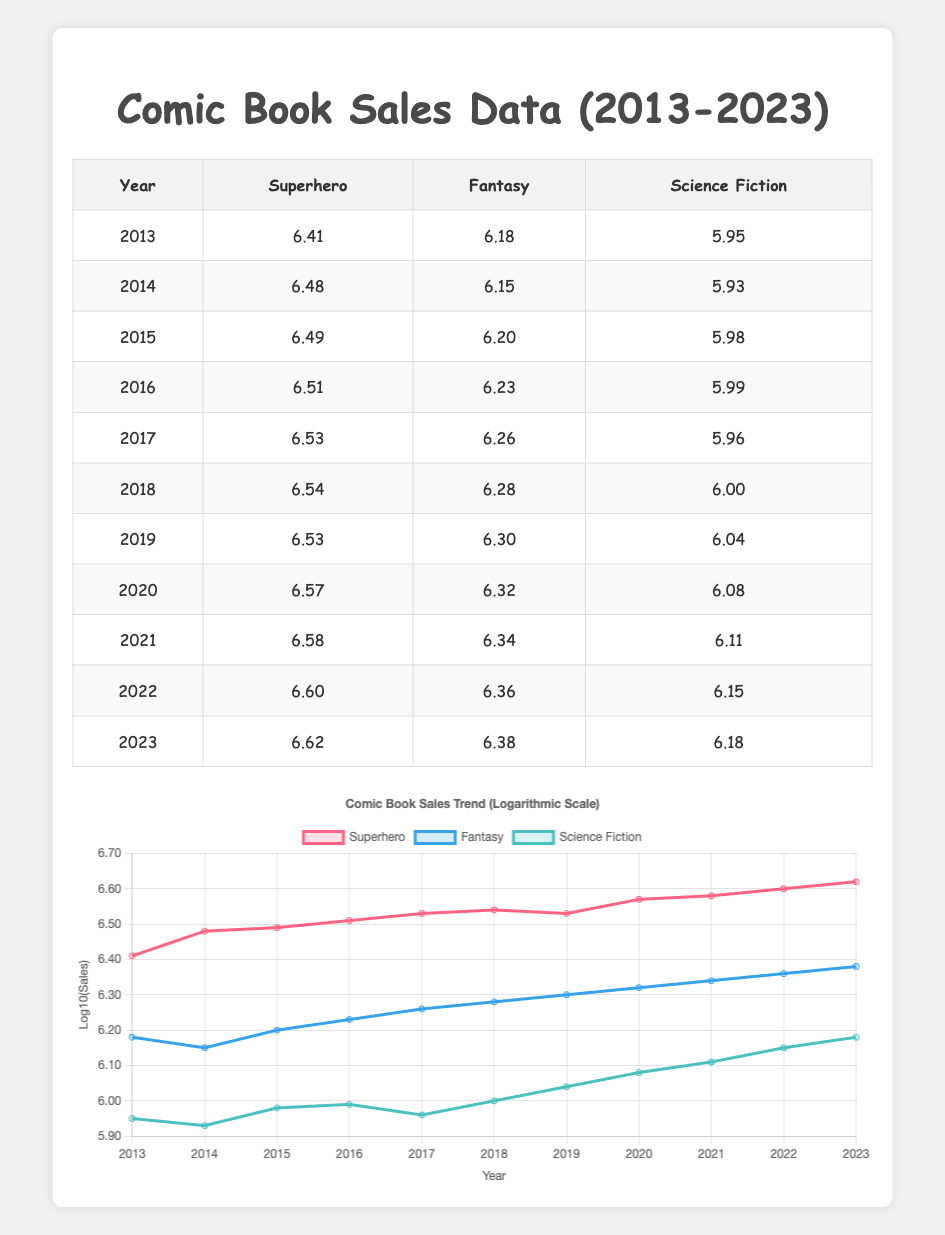What genre had the highest sales in 2023? In the year 2023, the Superhero genre had sales of 4,200,000, which is greater than the sales for both Fantasy (2,400,000) and Science Fiction (1,500,000). Therefore, Superhero had the highest sales.
Answer: Superhero What was the sales figure for Fantasy in 2016? The table shows that the sales figure for the Fantasy genre in 2016 was 1,700,000.
Answer: 1,700,000 Which year had the lowest sales for Science Fiction? By inspecting the table, the year with the lowest sales for Science Fiction was 2013, which had sales of 900,000, lower than all other years listed.
Answer: 2013 Calculate the total sales for Superhero from 2013 to 2023. Adding the sales figures for Superhero for each year gives: 2,600,000 + 3,000,000 + 3,100,000 + 3,200,000 + 3,400,000 + 3,500,000 + 3,400,000 + 3,700,000 + 3,800,000 + 4,000,000 + 4,200,000 = 37,600,000.
Answer: 37,600,000 Is it true that sales for Fantasy increased every year from 2013 to 2023? By examining the sales figures in the Fantasy genre, we see that they were: 1,500,000 (2013), 1,400,000 (2014), 1,600,000 (2015), 1,700,000 (2016), 1,800,000 (2017), 1,900,000 (2018), 2,000,000 (2019), 2,100,000 (2020), 2,200,000 (2021), 2,300,000 (2022), and 2,400,000 (2023). The 2014 figure was lower than 2013, which indicates a decrease. Therefore, the statement is false.
Answer: No Which genre saw an increase in sales between 2021 and 2022? The Superhero genre increased from 3,800,000 in 2021 to 4,000,000 in 2022, the Fantasy genre increased from 2,200,000 to 2,300,000, and the Science Fiction genre increased from 1,300,000 to 1,400,000. All genres saw an increase in sales.
Answer: Yes 